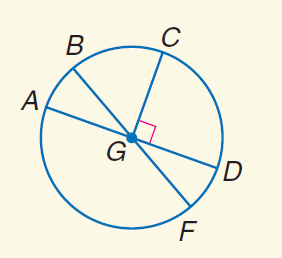Answer the mathemtical geometry problem and directly provide the correct option letter.
Question: In \odot G, m \angle A G B = 30 and C G \perp G D. Find m \widehat F D.
Choices: A: 30 B: 45 C: 90 D: 135 A 